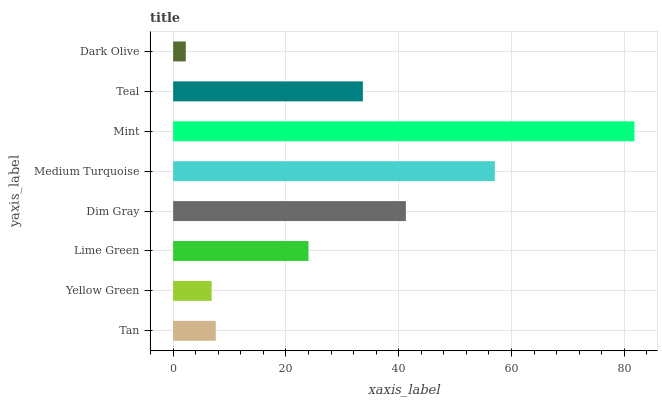Is Dark Olive the minimum?
Answer yes or no. Yes. Is Mint the maximum?
Answer yes or no. Yes. Is Yellow Green the minimum?
Answer yes or no. No. Is Yellow Green the maximum?
Answer yes or no. No. Is Tan greater than Yellow Green?
Answer yes or no. Yes. Is Yellow Green less than Tan?
Answer yes or no. Yes. Is Yellow Green greater than Tan?
Answer yes or no. No. Is Tan less than Yellow Green?
Answer yes or no. No. Is Teal the high median?
Answer yes or no. Yes. Is Lime Green the low median?
Answer yes or no. Yes. Is Mint the high median?
Answer yes or no. No. Is Teal the low median?
Answer yes or no. No. 